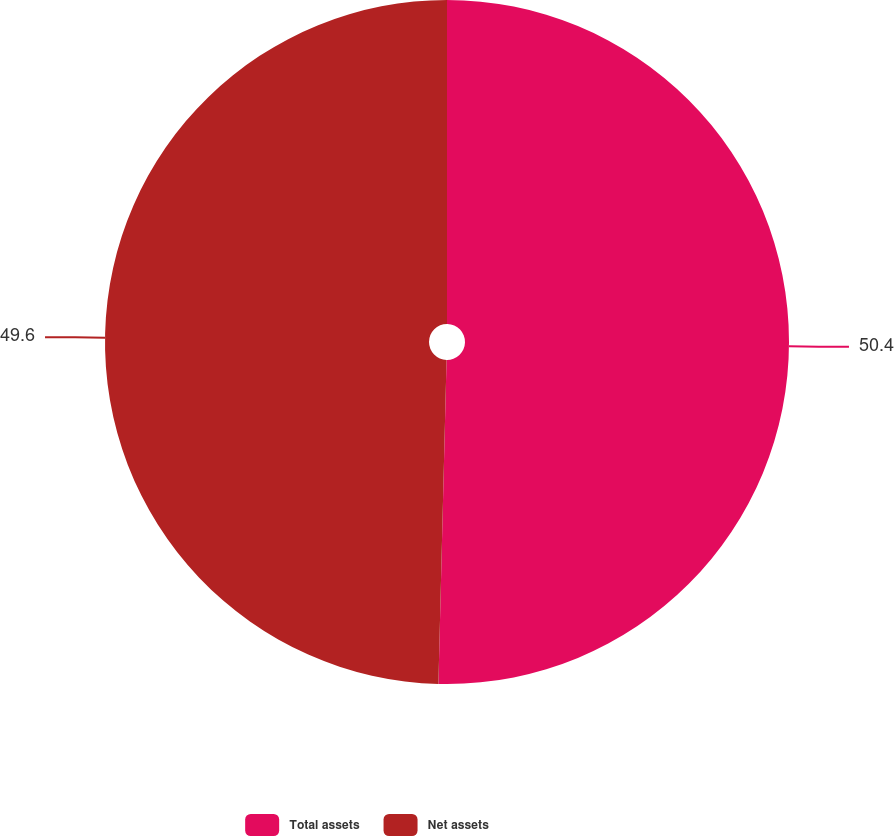<chart> <loc_0><loc_0><loc_500><loc_500><pie_chart><fcel>Total assets<fcel>Net assets<nl><fcel>50.4%<fcel>49.6%<nl></chart> 